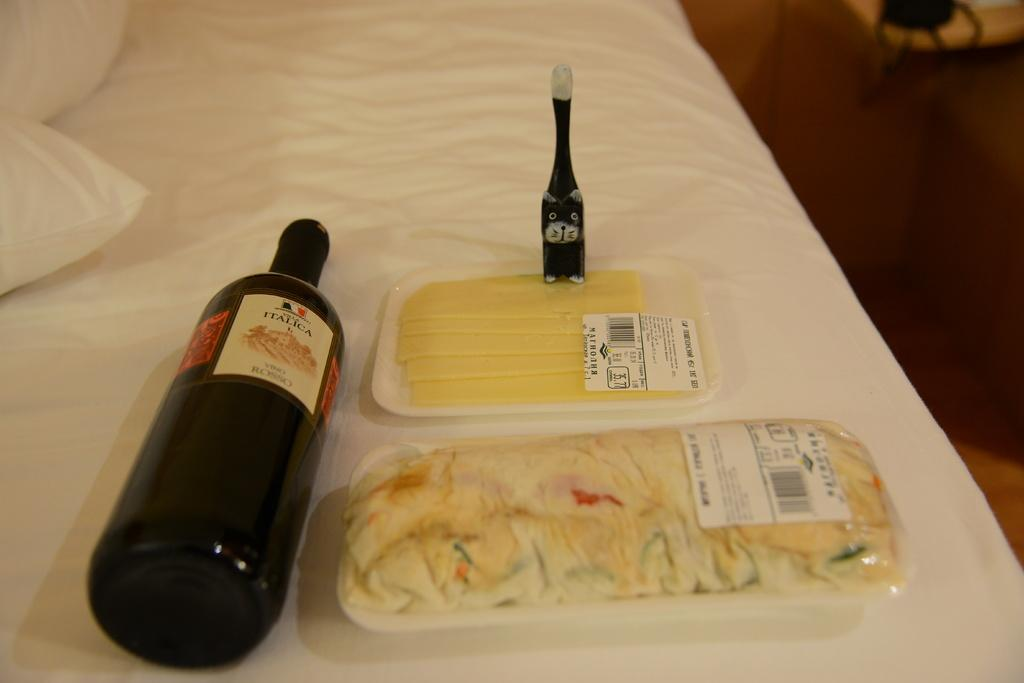<image>
Offer a succinct explanation of the picture presented. A bottle of Italica sits on it's side on a table. 